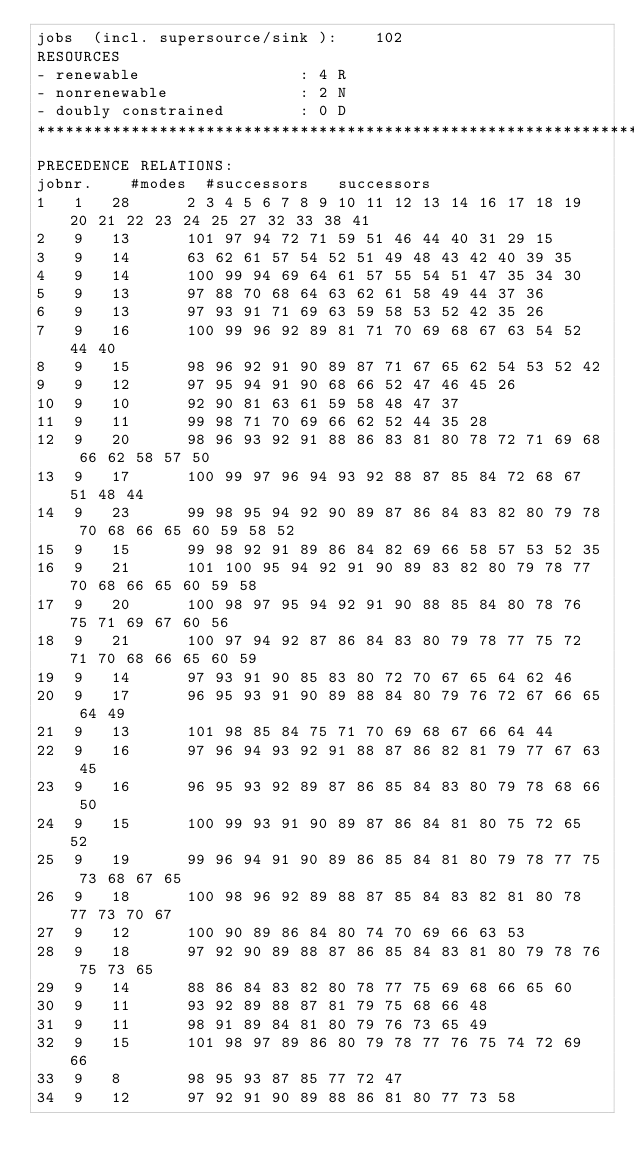Convert code to text. <code><loc_0><loc_0><loc_500><loc_500><_ObjectiveC_>jobs  (incl. supersource/sink ):	102
RESOURCES
- renewable                 : 4 R
- nonrenewable              : 2 N
- doubly constrained        : 0 D
************************************************************************
PRECEDENCE RELATIONS:
jobnr.    #modes  #successors   successors
1	1	28		2 3 4 5 6 7 8 9 10 11 12 13 14 16 17 18 19 20 21 22 23 24 25 27 32 33 38 41 
2	9	13		101 97 94 72 71 59 51 46 44 40 31 29 15 
3	9	14		63 62 61 57 54 52 51 49 48 43 42 40 39 35 
4	9	14		100 99 94 69 64 61 57 55 54 51 47 35 34 30 
5	9	13		97 88 70 68 64 63 62 61 58 49 44 37 36 
6	9	13		97 93 91 71 69 63 59 58 53 52 42 35 26 
7	9	16		100 99 96 92 89 81 71 70 69 68 67 63 54 52 44 40 
8	9	15		98 96 92 91 90 89 87 71 67 65 62 54 53 52 42 
9	9	12		97 95 94 91 90 68 66 52 47 46 45 26 
10	9	10		92 90 81 63 61 59 58 48 47 37 
11	9	11		99 98 71 70 69 66 62 52 44 35 28 
12	9	20		98 96 93 92 91 88 86 83 81 80 78 72 71 69 68 66 62 58 57 50 
13	9	17		100 99 97 96 94 93 92 88 87 85 84 72 68 67 51 48 44 
14	9	23		99 98 95 94 92 90 89 87 86 84 83 82 80 79 78 70 68 66 65 60 59 58 52 
15	9	15		99 98 92 91 89 86 84 82 69 66 58 57 53 52 35 
16	9	21		101 100 95 94 92 91 90 89 83 82 80 79 78 77 70 68 66 65 60 59 58 
17	9	20		100 98 97 95 94 92 91 90 88 85 84 80 78 76 75 71 69 67 60 56 
18	9	21		100 97 94 92 87 86 84 83 80 79 78 77 75 72 71 70 68 66 65 60 59 
19	9	14		97 93 91 90 85 83 80 72 70 67 65 64 62 46 
20	9	17		96 95 93 91 90 89 88 84 80 79 76 72 67 66 65 64 49 
21	9	13		101 98 85 84 75 71 70 69 68 67 66 64 44 
22	9	16		97 96 94 93 92 91 88 87 86 82 81 79 77 67 63 45 
23	9	16		96 95 93 92 89 87 86 85 84 83 80 79 78 68 66 50 
24	9	15		100 99 93 91 90 89 87 86 84 81 80 75 72 65 52 
25	9	19		99 96 94 91 90 89 86 85 84 81 80 79 78 77 75 73 68 67 65 
26	9	18		100 98 96 92 89 88 87 85 84 83 82 81 80 78 77 73 70 67 
27	9	12		100 90 89 86 84 80 74 70 69 66 63 53 
28	9	18		97 92 90 89 88 87 86 85 84 83 81 80 79 78 76 75 73 65 
29	9	14		88 86 84 83 82 80 78 77 75 69 68 66 65 60 
30	9	11		93 92 89 88 87 81 79 75 68 66 48 
31	9	11		98 91 89 84 81 80 79 76 73 65 49 
32	9	15		101 98 97 89 86 80 79 78 77 76 75 74 72 69 66 
33	9	8		98 95 93 87 85 77 72 47 
34	9	12		97 92 91 90 89 88 86 81 80 77 73 58 </code> 